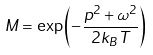<formula> <loc_0><loc_0><loc_500><loc_500>M = \exp \left ( - \frac { p ^ { 2 } + \omega ^ { 2 } } { 2 k _ { B } T } \right )</formula> 